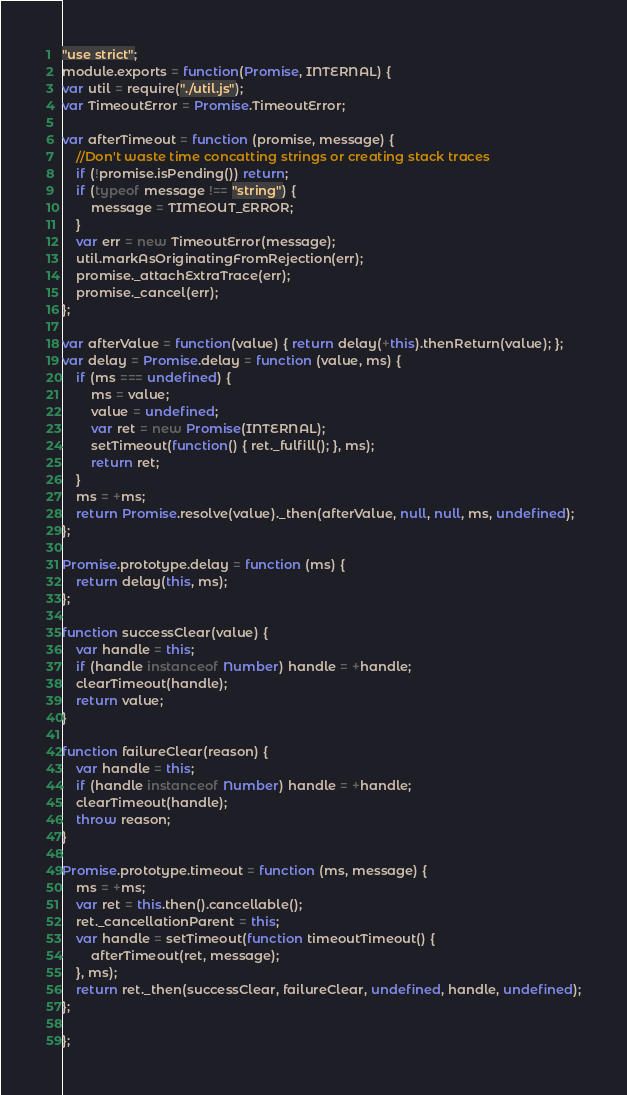Convert code to text. <code><loc_0><loc_0><loc_500><loc_500><_JavaScript_>"use strict";
module.exports = function(Promise, INTERNAL) {
var util = require("./util.js");
var TimeoutError = Promise.TimeoutError;

var afterTimeout = function (promise, message) {
    //Don't waste time concatting strings or creating stack traces
    if (!promise.isPending()) return;
    if (typeof message !== "string") {
        message = TIMEOUT_ERROR;
    }
    var err = new TimeoutError(message);
    util.markAsOriginatingFromRejection(err);
    promise._attachExtraTrace(err);
    promise._cancel(err);
};

var afterValue = function(value) { return delay(+this).thenReturn(value); };
var delay = Promise.delay = function (value, ms) {
    if (ms === undefined) {
        ms = value;
        value = undefined;
        var ret = new Promise(INTERNAL);
        setTimeout(function() { ret._fulfill(); }, ms);
        return ret;
    }
    ms = +ms;
    return Promise.resolve(value)._then(afterValue, null, null, ms, undefined);
};

Promise.prototype.delay = function (ms) {
    return delay(this, ms);
};

function successClear(value) {
    var handle = this;
    if (handle instanceof Number) handle = +handle;
    clearTimeout(handle);
    return value;
}

function failureClear(reason) {
    var handle = this;
    if (handle instanceof Number) handle = +handle;
    clearTimeout(handle);
    throw reason;
}

Promise.prototype.timeout = function (ms, message) {
    ms = +ms;
    var ret = this.then().cancellable();
    ret._cancellationParent = this;
    var handle = setTimeout(function timeoutTimeout() {
        afterTimeout(ret, message);
    }, ms);
    return ret._then(successClear, failureClear, undefined, handle, undefined);
};

};
</code> 